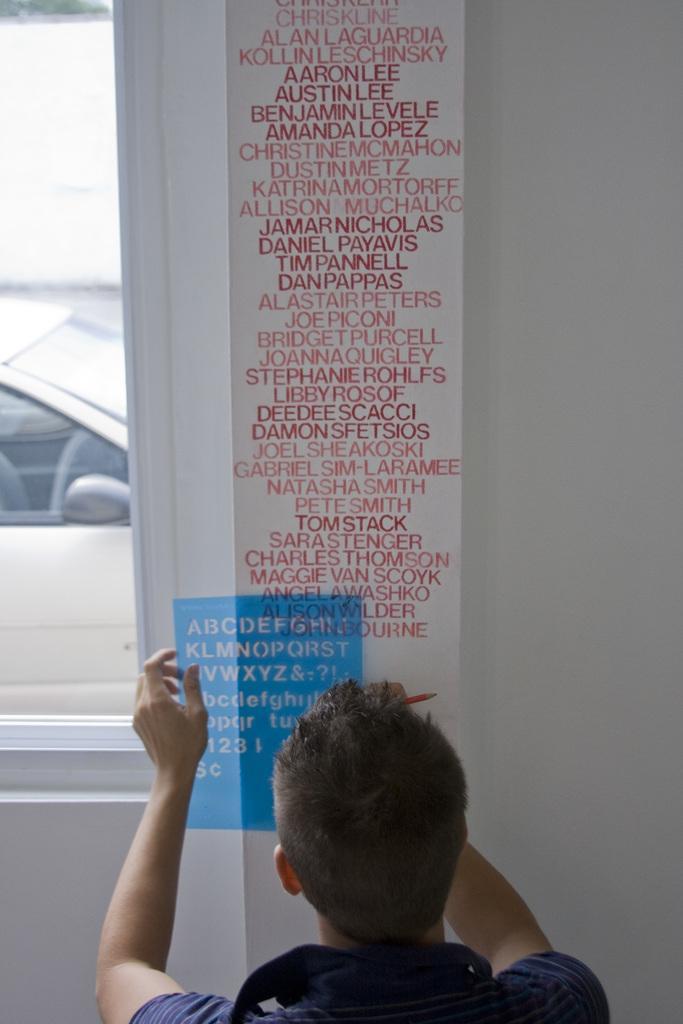How would you summarize this image in a sentence or two? In the picture I can see a person wearing a dress is holding a pencil and a blue color alphabet scale. Here we can see some written text which is in the red color on the wall. Here we can see the glass windows through which we can see a car in the background. 